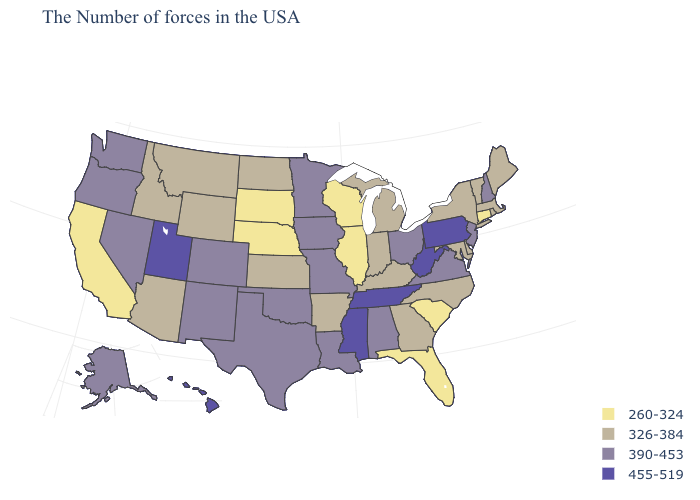Name the states that have a value in the range 455-519?
Be succinct. Pennsylvania, West Virginia, Tennessee, Mississippi, Utah, Hawaii. Is the legend a continuous bar?
Keep it brief. No. Name the states that have a value in the range 455-519?
Write a very short answer. Pennsylvania, West Virginia, Tennessee, Mississippi, Utah, Hawaii. Name the states that have a value in the range 390-453?
Concise answer only. New Hampshire, New Jersey, Virginia, Ohio, Alabama, Louisiana, Missouri, Minnesota, Iowa, Oklahoma, Texas, Colorado, New Mexico, Nevada, Washington, Oregon, Alaska. Name the states that have a value in the range 260-324?
Short answer required. Connecticut, South Carolina, Florida, Wisconsin, Illinois, Nebraska, South Dakota, California. Name the states that have a value in the range 260-324?
Keep it brief. Connecticut, South Carolina, Florida, Wisconsin, Illinois, Nebraska, South Dakota, California. Does the map have missing data?
Quick response, please. No. Among the states that border Michigan , does Ohio have the highest value?
Short answer required. Yes. Name the states that have a value in the range 326-384?
Write a very short answer. Maine, Massachusetts, Rhode Island, Vermont, New York, Delaware, Maryland, North Carolina, Georgia, Michigan, Kentucky, Indiana, Arkansas, Kansas, North Dakota, Wyoming, Montana, Arizona, Idaho. What is the highest value in the USA?
Keep it brief. 455-519. Name the states that have a value in the range 455-519?
Short answer required. Pennsylvania, West Virginia, Tennessee, Mississippi, Utah, Hawaii. Is the legend a continuous bar?
Keep it brief. No. Does the map have missing data?
Give a very brief answer. No. How many symbols are there in the legend?
Concise answer only. 4. Which states hav the highest value in the South?
Be succinct. West Virginia, Tennessee, Mississippi. 